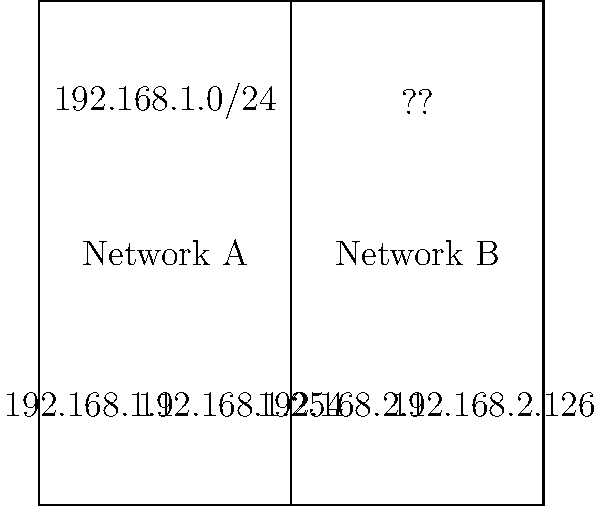Given the network diagram above, what subnet mask should be used for Network B to accommodate the maximum number of hosts while ensuring that the IP address 192.168.2.126 is within the valid host range? To determine the appropriate subnet mask for Network B, we'll follow these steps:

1. Analyze the given IP addresses:
   - Network A uses 192.168.1.0/24
   - Network B uses addresses in the range 192.168.2.1 to 192.168.2.126

2. Determine the number of host bits needed:
   - The highest host address is 192.168.2.126
   - In binary, 126 is 01111110
   - We need 7 bits to represent all hosts from 1 to 126

3. Calculate the subnet mask:
   - Total IP address bits: 32
   - Network bits: 32 - 7 = 25
   - Subnet mask in binary: 11111111.11111111.11111111.10000000

4. Convert the subnet mask to decimal:
   255.255.255.128

5. Verify the subnet:
   - Network address: 192.168.2.0
   - Broadcast address: 192.168.2.127
   - Valid host range: 192.168.2.1 to 192.168.2.126

This subnet mask (255.255.255.128 or /25) accommodates up to 126 hosts and includes the address 192.168.2.126 within the valid host range.
Answer: 255.255.255.128 (/25) 